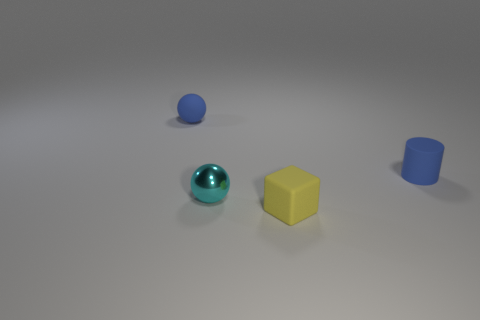Do the metal ball and the blue sphere have the same size?
Provide a short and direct response. Yes. There is a object that is behind the tiny object on the right side of the tiny yellow object; what is its color?
Provide a short and direct response. Blue. What color is the matte cylinder?
Your response must be concise. Blue. Is there a tiny ball that has the same color as the tiny rubber cylinder?
Ensure brevity in your answer.  Yes. There is a tiny rubber object on the right side of the small yellow block; is its color the same as the small matte ball?
Your answer should be compact. Yes. How many things are either tiny blue things to the right of the small yellow rubber block or shiny spheres?
Provide a succinct answer. 2. There is a cyan ball; are there any small cyan spheres in front of it?
Your answer should be very brief. No. Does the ball that is left of the small cyan metal sphere have the same material as the yellow object?
Provide a succinct answer. Yes. There is a yellow block that is in front of the blue thing that is on the right side of the tiny yellow cube; is there a tiny matte sphere behind it?
Offer a terse response. Yes. What number of balls are either big blue objects or cyan metal objects?
Your response must be concise. 1. 